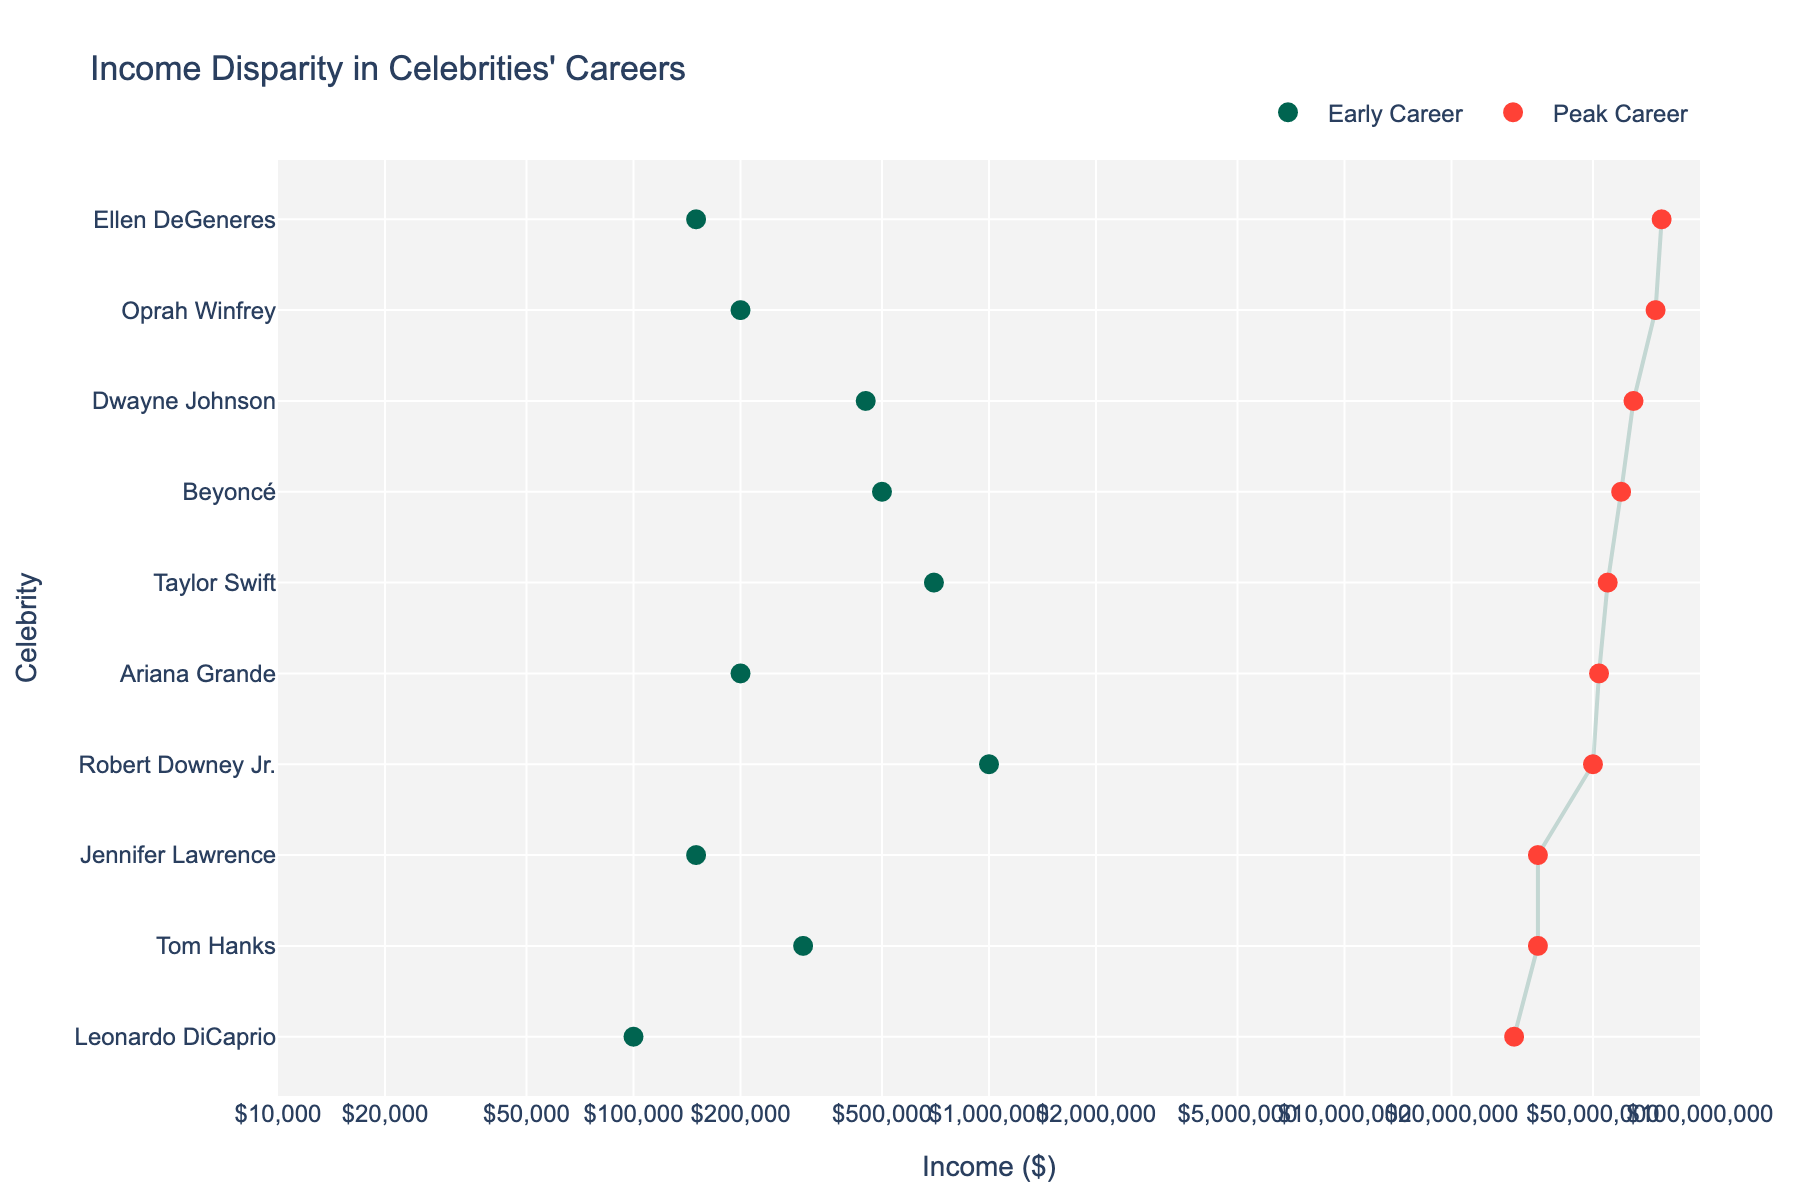what is the title of the figure? The title of the figure is usually prominently displayed at the top of the plot. Just look at the top area above the plotted data to find it.
Answer: Income Disparity in Celebrities' Careers what are the axis labels used in the plot? The axis labels are found on the horizontal and vertical sides of the plot, indicating what each axis represents.
Answer: y-axis: Celebrity, x-axis: Income ($) how many celebrities are included in the figure? Each celebrity corresponds to a separate entry on the y-axis, so count the number of unique entries listed on the y-axis.
Answer: 10 which celebrity has the highest peak career income? By identifying the peak career income points (red markers) and finding the highest value on the x-axis, then checking the corresponding celebrity on the y-axis.
Answer: Ellen DeGeneres how much more is the peak career income of Leonardo DiCaprio than his early career income? Find Leonardo DiCaprio on the y-axis. Note his early career income (green marker) and peak career income (red marker) on the x-axis, then calculate the difference (30000000 - 100000).
Answer: 29900000 which celebrity shows the least disparity between their early and peak career incomes? Determine the disparity by finding the shortest distance (smallest gap) between the green and red markers on the x-axis for each celebrity.
Answer: Tom Hanks what’s the average peak career income of all celebrities? Sum the peak career incomes for all celebrities and then divide by the total number of celebrities. Example: (30000000 + 75000000 + 60000000 + 50000000 + 55000000 + 78000000 + 65000000 + 52000000 + 35000000 + 35000000)/10.
Answer: 53,650,000 how does Ariana Grande's early career income compare to Robert Downey Jr.'s early career income? Locate both celebrities on the y-axis. Compare the values of their early career incomes (green markers) on the x-axis.
Answer: Less than which two celebrities have the same peak career income? Identify identical values among the peak career incomes (red markers) and find the corresponding celebrities.
Answer: Tom Hanks and Jennifer Lawrence what is the total early career income of Beyoncé and Taylor Swift combined? Find their early career incomes on the x-axis and sum them up (500000 + 700000).
Answer: 1200000 